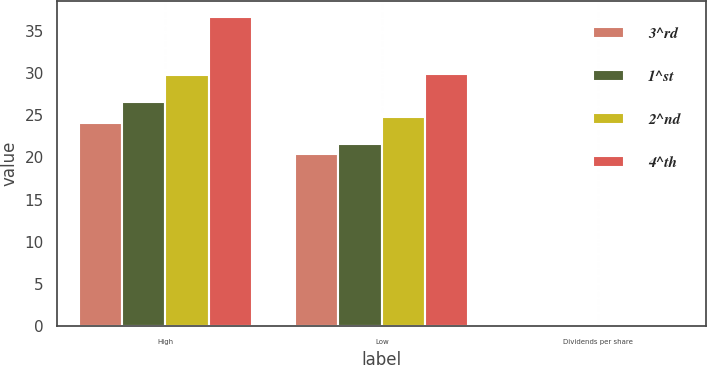Convert chart to OTSL. <chart><loc_0><loc_0><loc_500><loc_500><stacked_bar_chart><ecel><fcel>High<fcel>Low<fcel>Dividends per share<nl><fcel>3^rd<fcel>24.06<fcel>20.38<fcel>0.08<nl><fcel>1^st<fcel>26.6<fcel>21.54<fcel>0.08<nl><fcel>2^nd<fcel>29.79<fcel>24.77<fcel>0.1<nl><fcel>4^th<fcel>36.69<fcel>29.88<fcel>0.1<nl></chart> 